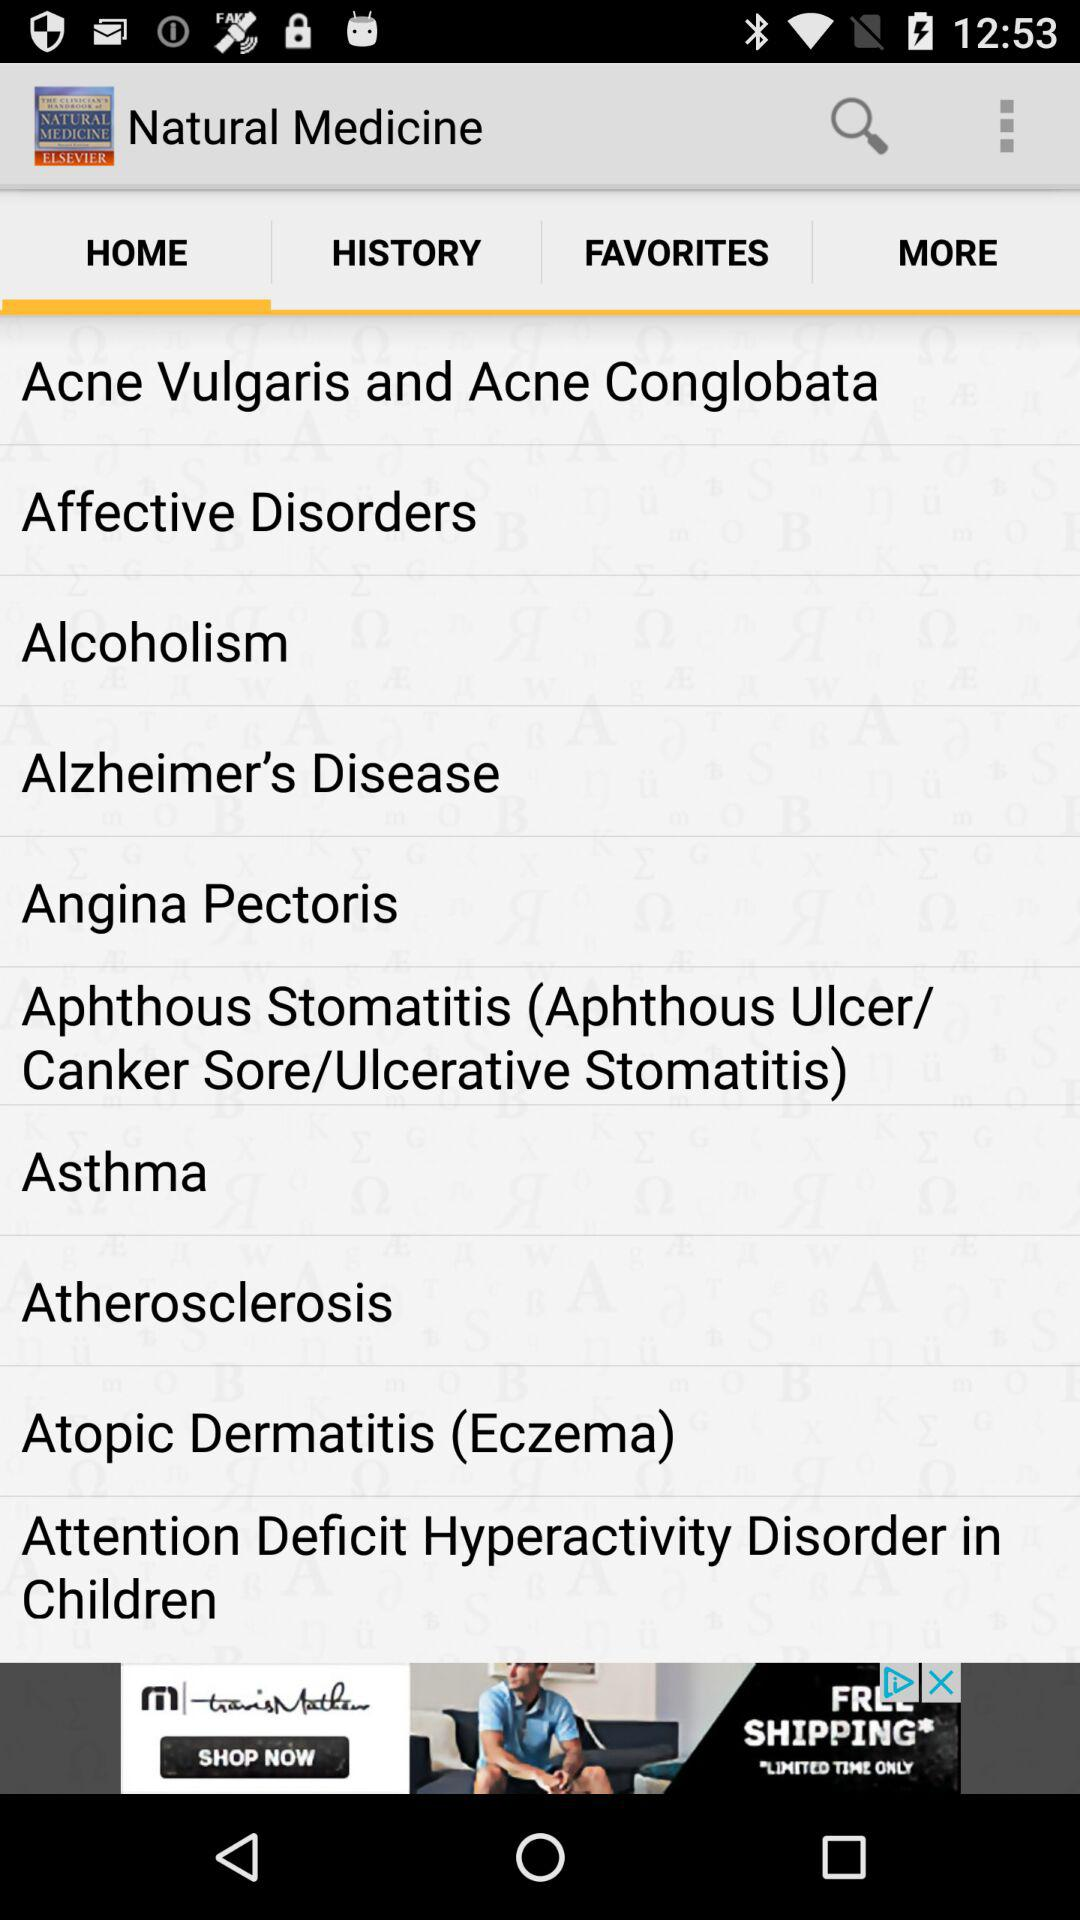What is the name of the application? The name of the application is "Natural Medicine". 